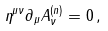Convert formula to latex. <formula><loc_0><loc_0><loc_500><loc_500>\eta ^ { \mu \nu } \partial _ { \mu } A ^ { ( n ) } _ { \nu } = 0 \, ,</formula> 